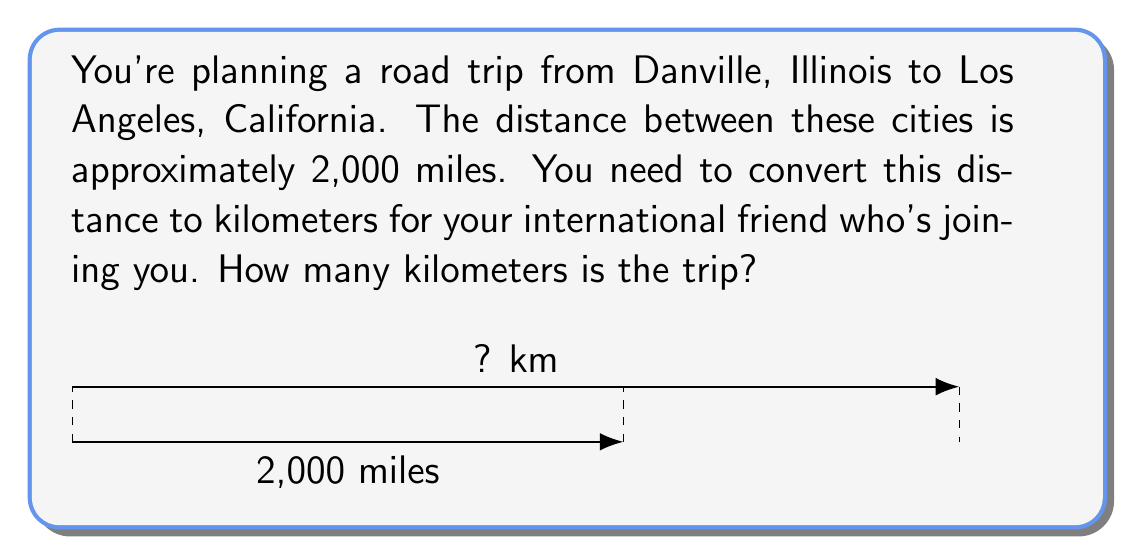Help me with this question. To convert miles to kilometers, we need to use the conversion factor:
1 mile ≈ 1.60934 kilometers

Let's set up the conversion:
$$ 2000 \text{ miles} \times \frac{1.60934 \text{ km}}{1 \text{ mile}} $$

Now, let's calculate:
$$ 2000 \times 1.60934 = 3218.68 \text{ km} $$

Rounding to the nearest whole number (since we're dealing with a large distance):
$$ 3218.68 \text{ km} \approx 3219 \text{ km} $$

Therefore, the 2,000-mile trip from Danville to Los Angeles is approximately 3,219 kilometers.
Answer: 3,219 km 